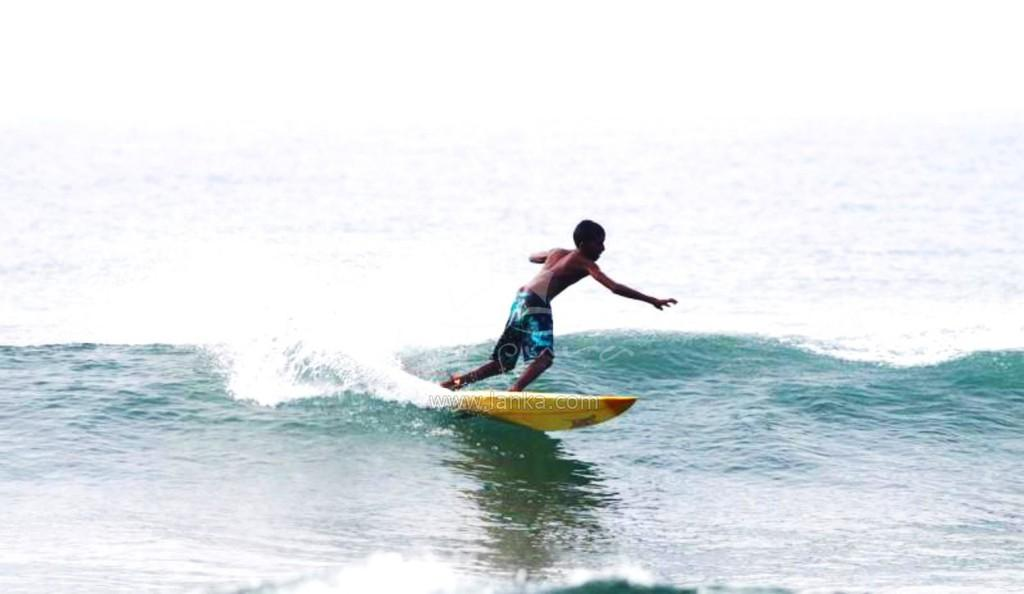Who or what is the main subject in the image? There is a person in the image. What is the person doing in the image? The person is standing on a surfing board. Where is the surfing board located? The surfing board is on a river. What type of silver material is being used to teach the person how to surf in the image? There is no silver material or teaching activity present in the image. 